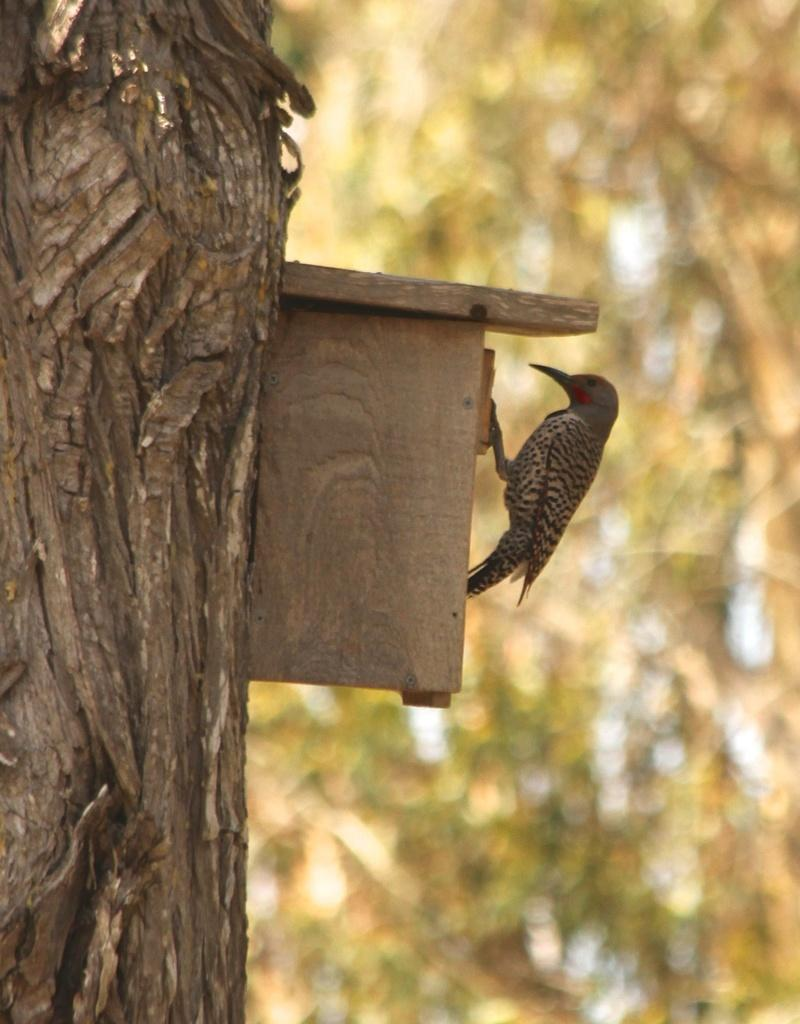What animal can be seen in the image? There is a bird in the image. Where is the bird located? The bird is on a wooden box. What can be seen on the left side of the image? There is a tree stem on the left side of the image. What is visible in the background of the image? There are trees in the background of the image. How is the background of the image depicted? The background of the image is blurred. Can you see a toothbrush being used by the bird in the image? There is no toothbrush present in the image, and the bird is not using one. 